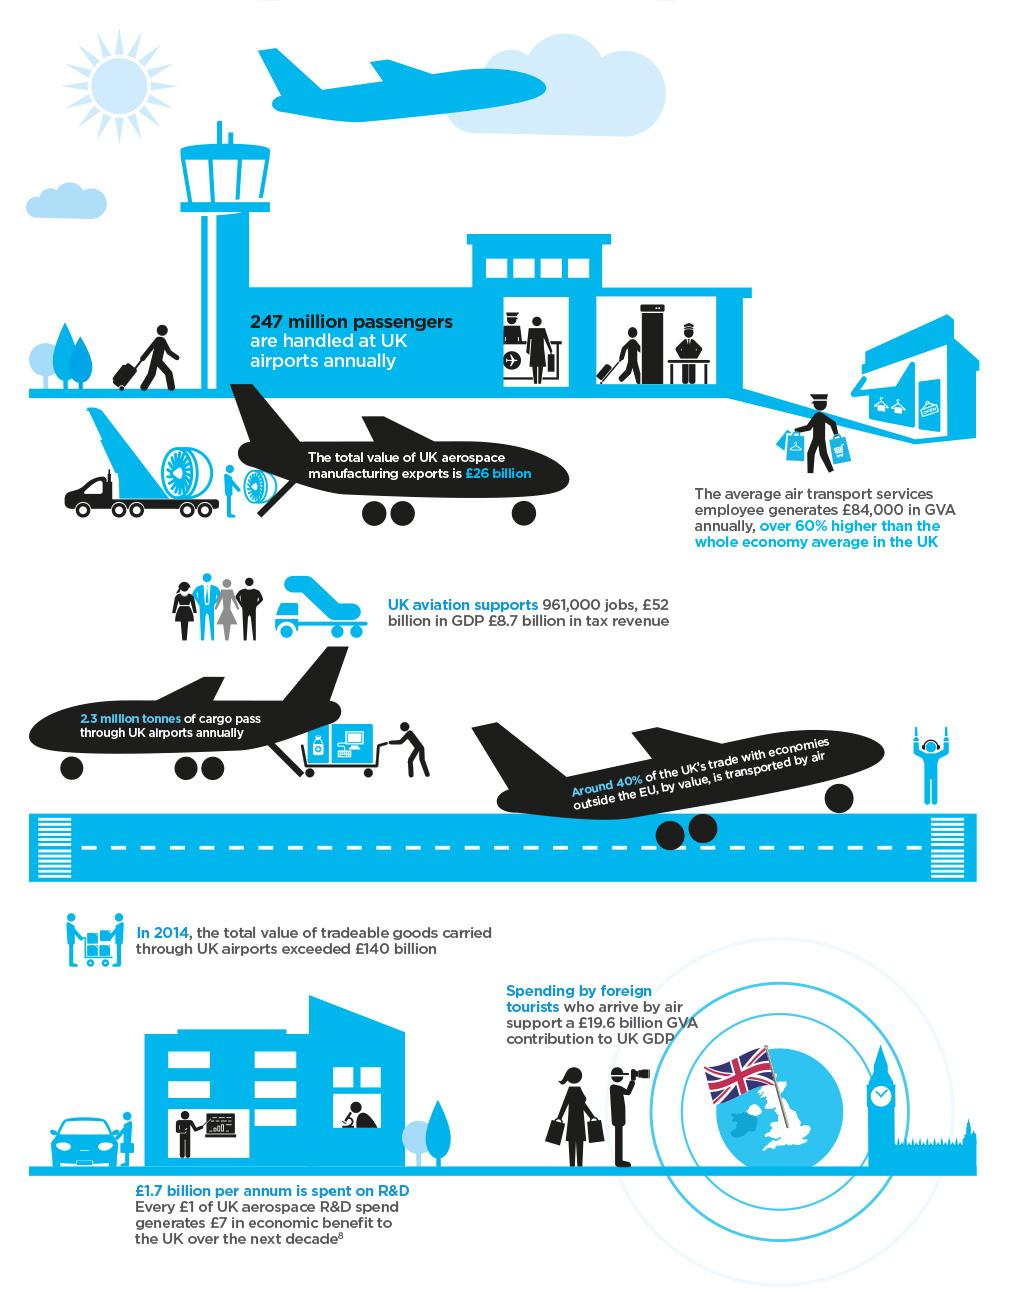Outline some significant characteristics in this image. In the UK's aviation industry, approximately 961,000 people are employed. The contribution of near to 20 billion pounds to the GDP is primarily due to the spending by foreign tourists. 